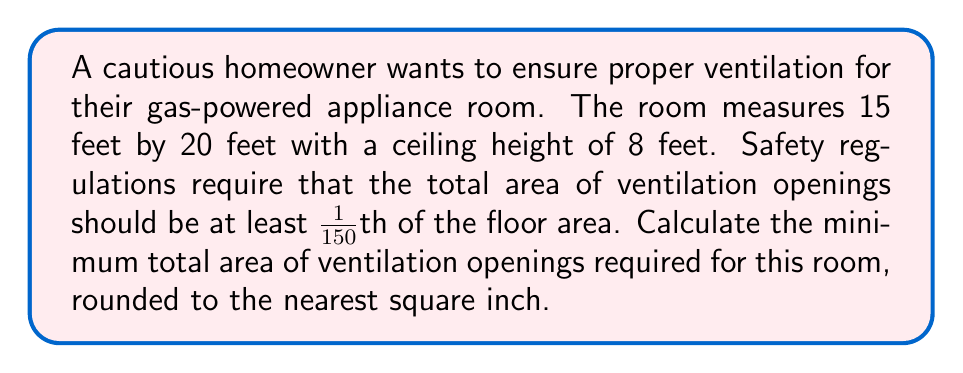Provide a solution to this math problem. Let's approach this step-by-step:

1) First, we need to calculate the floor area of the room:
   $$ \text{Floor Area} = \text{Length} \times \text{Width} $$
   $$ \text{Floor Area} = 15 \text{ ft} \times 20 \text{ ft} = 300 \text{ sq ft} $$

2) Now, we need to find 1/150th of this area:
   $$ \text{Ventilation Area} = \frac{\text{Floor Area}}{150} $$
   $$ \text{Ventilation Area} = \frac{300 \text{ sq ft}}{150} = 2 \text{ sq ft} $$

3) We need to convert this to square inches:
   $$ 2 \text{ sq ft} \times (12 \text{ in}/1 \text{ ft})^2 = 2 \times 144 = 288 \text{ sq in} $$

4) The question asks for the answer rounded to the nearest square inch, but 288 is already a whole number, so no rounding is necessary.
Answer: 288 sq in 